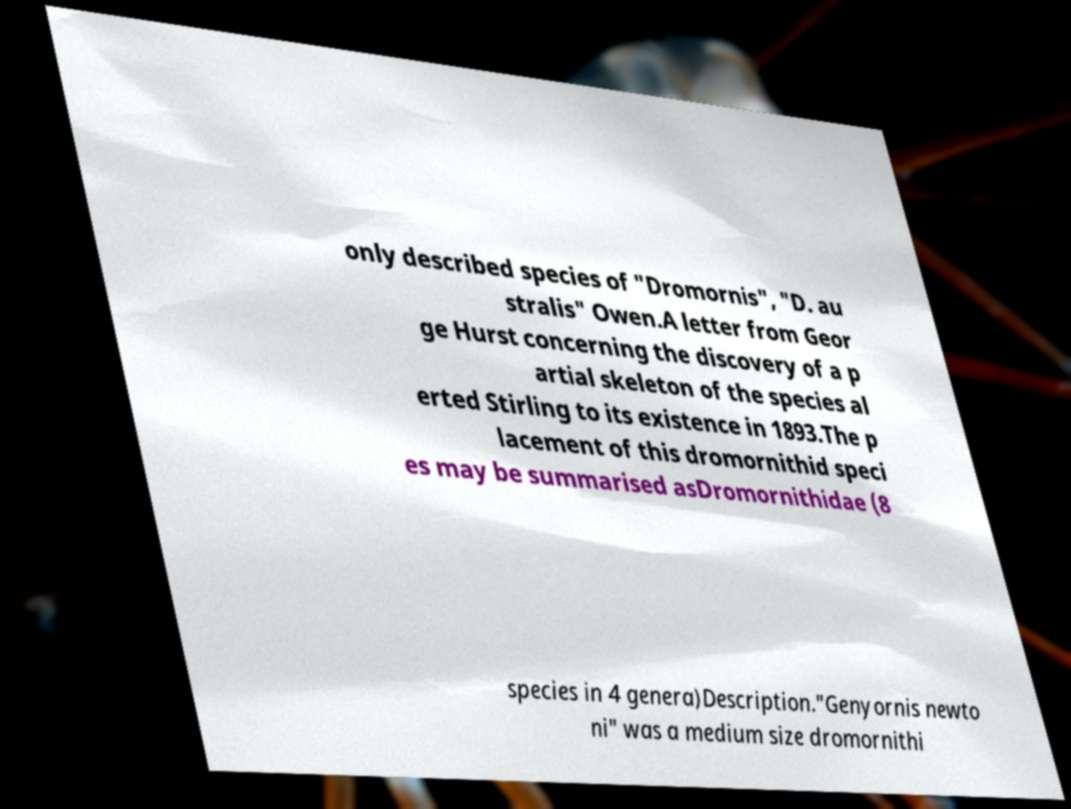What messages or text are displayed in this image? I need them in a readable, typed format. only described species of "Dromornis", "D. au stralis" Owen.A letter from Geor ge Hurst concerning the discovery of a p artial skeleton of the species al erted Stirling to its existence in 1893.The p lacement of this dromornithid speci es may be summarised asDromornithidae (8 species in 4 genera)Description."Genyornis newto ni" was a medium size dromornithi 